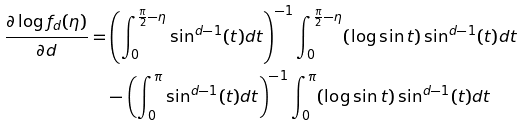<formula> <loc_0><loc_0><loc_500><loc_500>\frac { \partial \log f _ { d } ( \eta ) } { \partial d } = & \left ( \int _ { 0 } ^ { \frac { \pi } { 2 } - \eta } \sin ^ { d - 1 } ( t ) d t \right ) ^ { - 1 } \int _ { 0 } ^ { \frac { \pi } { 2 } - \eta } ( \log \sin t ) \sin ^ { d - 1 } ( t ) d t \\ & - \left ( \int _ { 0 } ^ { \pi } \sin ^ { d - 1 } ( t ) d t \right ) ^ { - 1 } \int _ { 0 } ^ { \pi } ( \log \sin t ) \sin ^ { d - 1 } ( t ) d t</formula> 